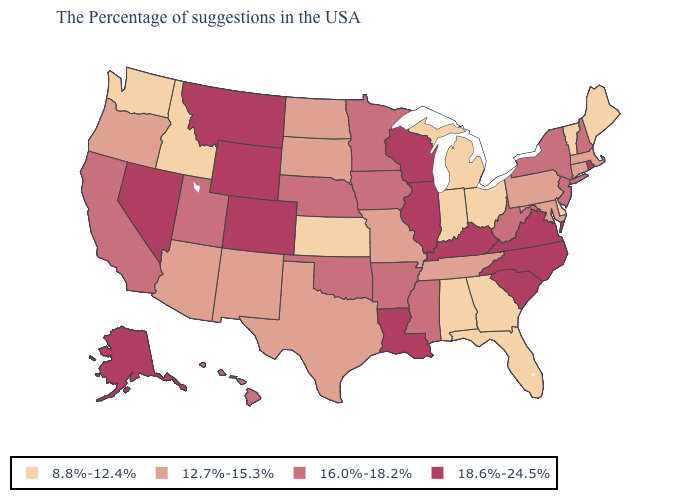Which states have the lowest value in the USA?
Answer briefly. Maine, Vermont, Delaware, Ohio, Florida, Georgia, Michigan, Indiana, Alabama, Kansas, Idaho, Washington. Name the states that have a value in the range 12.7%-15.3%?
Concise answer only. Massachusetts, Connecticut, Maryland, Pennsylvania, Tennessee, Missouri, Texas, South Dakota, North Dakota, New Mexico, Arizona, Oregon. What is the value of Colorado?
Short answer required. 18.6%-24.5%. How many symbols are there in the legend?
Quick response, please. 4. Name the states that have a value in the range 8.8%-12.4%?
Quick response, please. Maine, Vermont, Delaware, Ohio, Florida, Georgia, Michigan, Indiana, Alabama, Kansas, Idaho, Washington. Name the states that have a value in the range 18.6%-24.5%?
Be succinct. Rhode Island, Virginia, North Carolina, South Carolina, Kentucky, Wisconsin, Illinois, Louisiana, Wyoming, Colorado, Montana, Nevada, Alaska. Name the states that have a value in the range 16.0%-18.2%?
Quick response, please. New Hampshire, New York, New Jersey, West Virginia, Mississippi, Arkansas, Minnesota, Iowa, Nebraska, Oklahoma, Utah, California, Hawaii. What is the lowest value in the USA?
Short answer required. 8.8%-12.4%. Name the states that have a value in the range 16.0%-18.2%?
Short answer required. New Hampshire, New York, New Jersey, West Virginia, Mississippi, Arkansas, Minnesota, Iowa, Nebraska, Oklahoma, Utah, California, Hawaii. Which states have the highest value in the USA?
Answer briefly. Rhode Island, Virginia, North Carolina, South Carolina, Kentucky, Wisconsin, Illinois, Louisiana, Wyoming, Colorado, Montana, Nevada, Alaska. What is the value of South Dakota?
Be succinct. 12.7%-15.3%. Does Missouri have a higher value than Wyoming?
Write a very short answer. No. Does the map have missing data?
Keep it brief. No. What is the value of Kentucky?
Answer briefly. 18.6%-24.5%. Name the states that have a value in the range 18.6%-24.5%?
Keep it brief. Rhode Island, Virginia, North Carolina, South Carolina, Kentucky, Wisconsin, Illinois, Louisiana, Wyoming, Colorado, Montana, Nevada, Alaska. 